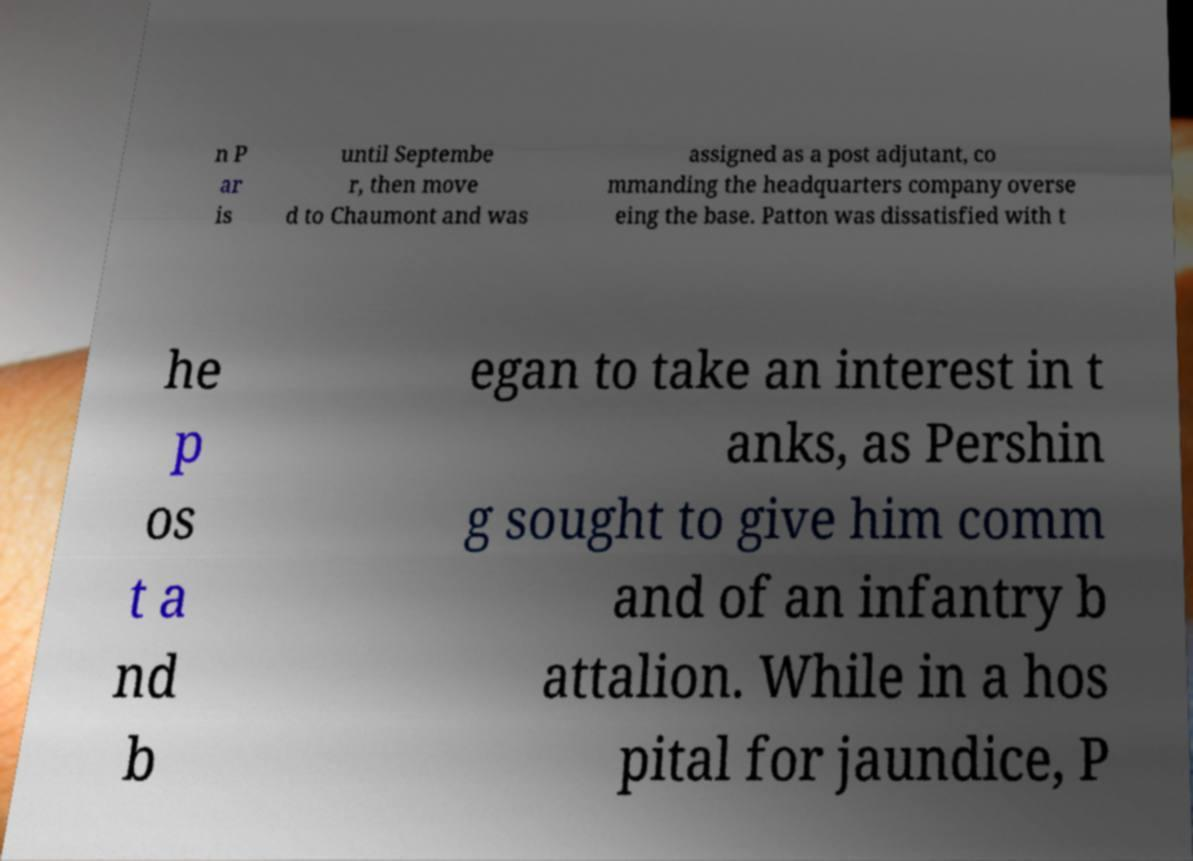Can you read and provide the text displayed in the image?This photo seems to have some interesting text. Can you extract and type it out for me? n P ar is until Septembe r, then move d to Chaumont and was assigned as a post adjutant, co mmanding the headquarters company overse eing the base. Patton was dissatisfied with t he p os t a nd b egan to take an interest in t anks, as Pershin g sought to give him comm and of an infantry b attalion. While in a hos pital for jaundice, P 